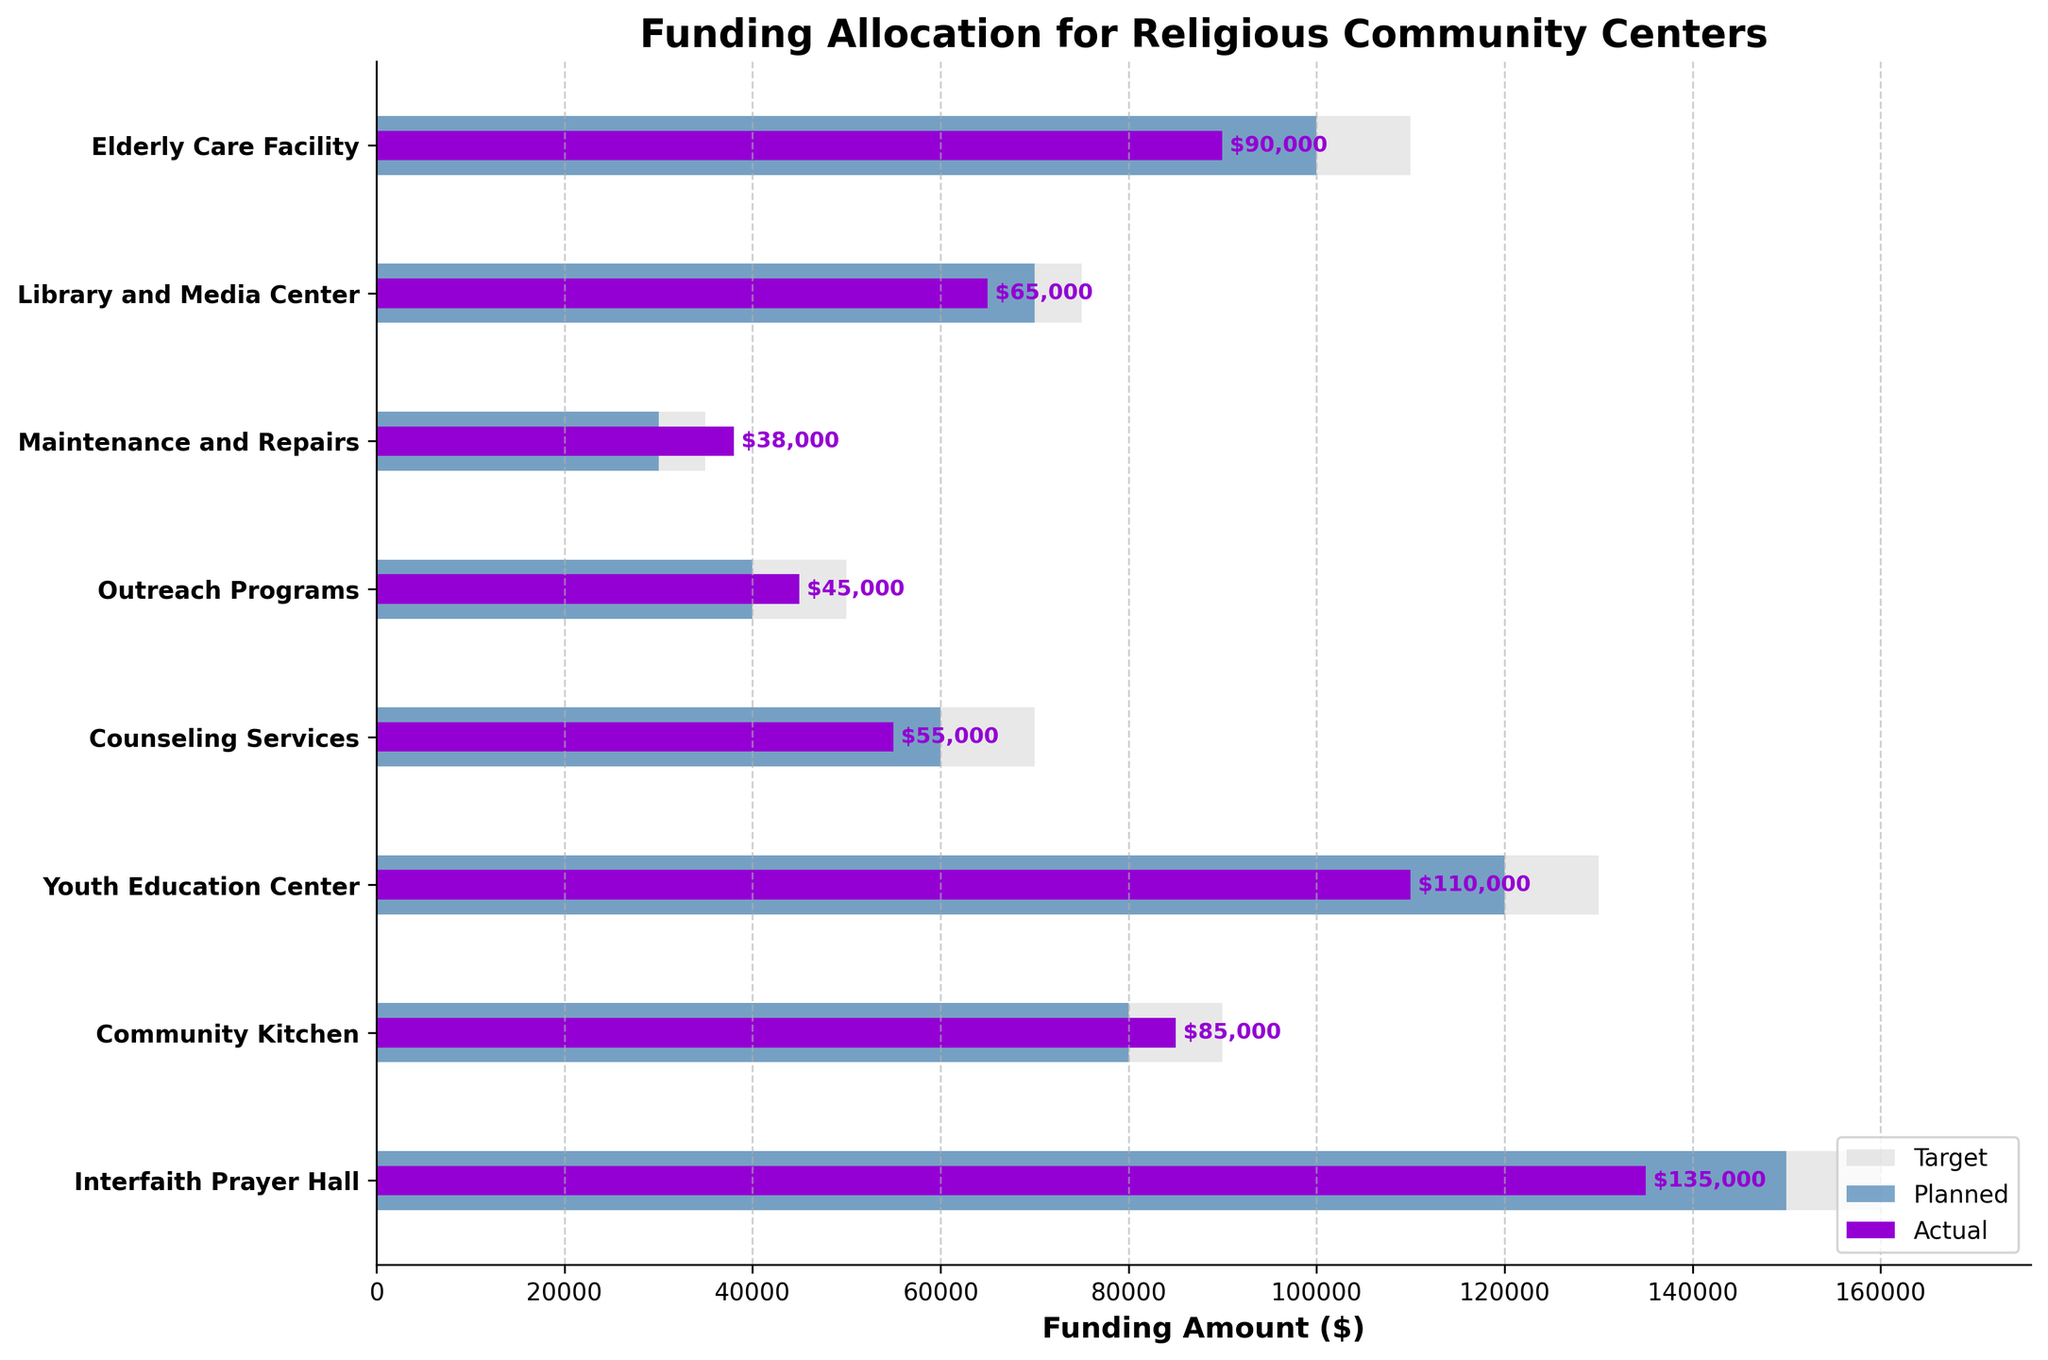what is the title of the figure? The title of the figure is typically located at the top of a plot and provides a succinct description of what the figure represents. In this case, it clearly states the focus of the plot regarding budget allocation.
Answer: Funding Allocation for Religious Community Centers Which category had the highest planned funding? The highest planned funding can be determined by looking at the length of the bars representing the planned funding. The longest bar represents the highest planned funding.
Answer: Interfaith Prayer Hall What's the actual funding for the Community Kitchen compared to its target? To find this, compare the position of the 'Actual' bar with the 'Target' bar for the Community Kitchen category.
Answer: $85,000 to $90,000 How many categories spent more than their planned budget? This requires counting the categories where the 'Actual' bar exceeds the 'Planned' bar.
Answer: 2 What is the difference between planned and actual funding for Youth Education Center? Subtract the 'Actual' funding amount from the 'Planned' funding amount for the Youth Education Center to get the difference.
Answer: $10,000 Which category had the largest shortfall between actual and target funding? To find this, calculate the difference between the 'Target' and 'Actual' bars for each category, then identify the largest value.
Answer: Elderly Care Facility In which category is actual funding closest to planned funding? Look for the category where the 'Actual' bar is closest in length to the 'Planned' bar.
Answer: Community Kitchen What is the total actual expenditure across all categories? Add the 'Actual' expenditure for each category: 135,000 + 85,000 + 110,000 + 55,000 + 45,000 + 38,000 + 65,000 + 90,000.
Answer: $623,000 How does funding for Outreach Programs compare to Counseling Services in terms of actual expenditure? Compare the lengths of the 'Actual' bars for Outreach Programs and Counseling Services.
Answer: $45,000 for Outreach Programs vs. $55,000 for Counseling Services Which category is underfunded when you compare planned and actual funding? Look for the categories where the 'Actual' funding is less than the 'Planned' funding and identify the largest gap.
Answer: Elderly Care Facility 